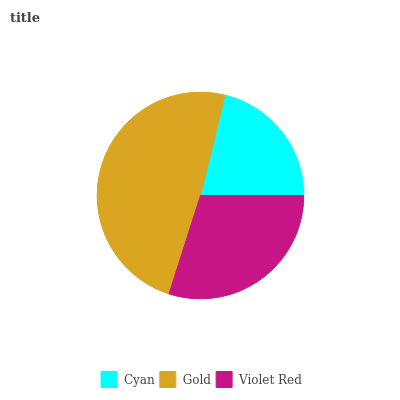Is Cyan the minimum?
Answer yes or no. Yes. Is Gold the maximum?
Answer yes or no. Yes. Is Violet Red the minimum?
Answer yes or no. No. Is Violet Red the maximum?
Answer yes or no. No. Is Gold greater than Violet Red?
Answer yes or no. Yes. Is Violet Red less than Gold?
Answer yes or no. Yes. Is Violet Red greater than Gold?
Answer yes or no. No. Is Gold less than Violet Red?
Answer yes or no. No. Is Violet Red the high median?
Answer yes or no. Yes. Is Violet Red the low median?
Answer yes or no. Yes. Is Gold the high median?
Answer yes or no. No. Is Cyan the low median?
Answer yes or no. No. 